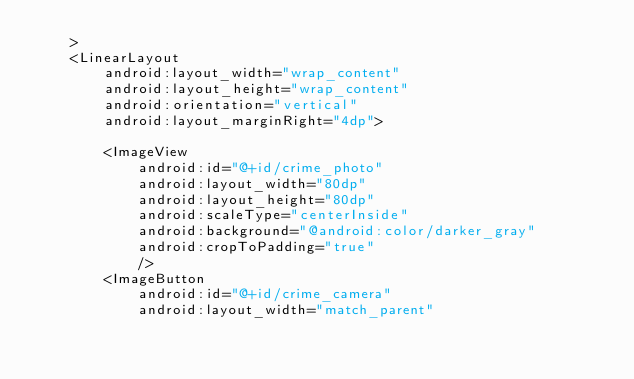<code> <loc_0><loc_0><loc_500><loc_500><_XML_>    >
    <LinearLayout
        android:layout_width="wrap_content"
        android:layout_height="wrap_content"
        android:orientation="vertical"
        android:layout_marginRight="4dp">

        <ImageView
            android:id="@+id/crime_photo"
            android:layout_width="80dp"
            android:layout_height="80dp"
            android:scaleType="centerInside"
            android:background="@android:color/darker_gray"
            android:cropToPadding="true"
            />
        <ImageButton
            android:id="@+id/crime_camera"
            android:layout_width="match_parent"</code> 